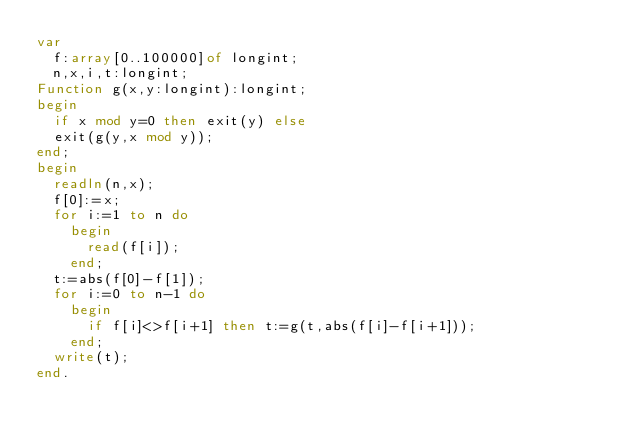Convert code to text. <code><loc_0><loc_0><loc_500><loc_500><_Pascal_>var
  f:array[0..100000]of longint;
  n,x,i,t:longint;
Function g(x,y:longint):longint;
begin
  if x mod y=0 then exit(y) else
  exit(g(y,x mod y));
end;
begin
  readln(n,x);
  f[0]:=x;
  for i:=1 to n do
    begin
      read(f[i]);
    end;
  t:=abs(f[0]-f[1]);
  for i:=0 to n-1 do
    begin
      if f[i]<>f[i+1] then t:=g(t,abs(f[i]-f[i+1]));
    end;
  write(t);
end.</code> 